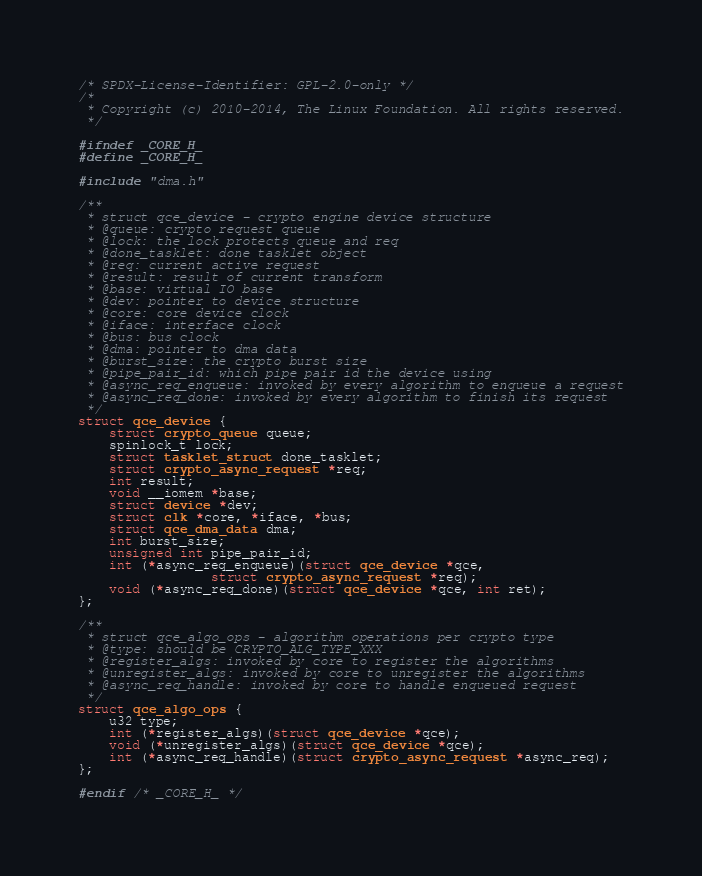<code> <loc_0><loc_0><loc_500><loc_500><_C_>/* SPDX-License-Identifier: GPL-2.0-only */
/*
 * Copyright (c) 2010-2014, The Linux Foundation. All rights reserved.
 */

#ifndef _CORE_H_
#define _CORE_H_

#include "dma.h"

/**
 * struct qce_device - crypto engine device structure
 * @queue: crypto request queue
 * @lock: the lock protects queue and req
 * @done_tasklet: done tasklet object
 * @req: current active request
 * @result: result of current transform
 * @base: virtual IO base
 * @dev: pointer to device structure
 * @core: core device clock
 * @iface: interface clock
 * @bus: bus clock
 * @dma: pointer to dma data
 * @burst_size: the crypto burst size
 * @pipe_pair_id: which pipe pair id the device using
 * @async_req_enqueue: invoked by every algorithm to enqueue a request
 * @async_req_done: invoked by every algorithm to finish its request
 */
struct qce_device {
	struct crypto_queue queue;
	spinlock_t lock;
	struct tasklet_struct done_tasklet;
	struct crypto_async_request *req;
	int result;
	void __iomem *base;
	struct device *dev;
	struct clk *core, *iface, *bus;
	struct qce_dma_data dma;
	int burst_size;
	unsigned int pipe_pair_id;
	int (*async_req_enqueue)(struct qce_device *qce,
				 struct crypto_async_request *req);
	void (*async_req_done)(struct qce_device *qce, int ret);
};

/**
 * struct qce_algo_ops - algorithm operations per crypto type
 * @type: should be CRYPTO_ALG_TYPE_XXX
 * @register_algs: invoked by core to register the algorithms
 * @unregister_algs: invoked by core to unregister the algorithms
 * @async_req_handle: invoked by core to handle enqueued request
 */
struct qce_algo_ops {
	u32 type;
	int (*register_algs)(struct qce_device *qce);
	void (*unregister_algs)(struct qce_device *qce);
	int (*async_req_handle)(struct crypto_async_request *async_req);
};

#endif /* _CORE_H_ */
</code> 